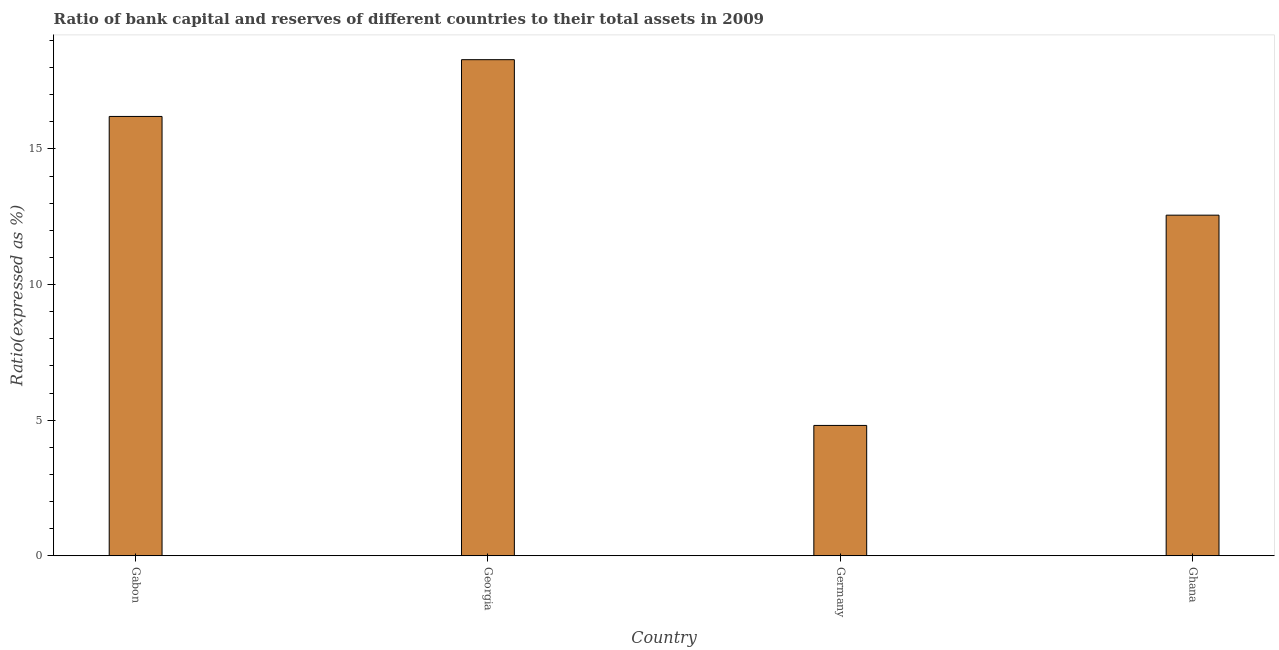What is the title of the graph?
Keep it short and to the point. Ratio of bank capital and reserves of different countries to their total assets in 2009. What is the label or title of the Y-axis?
Offer a very short reply. Ratio(expressed as %). What is the bank capital to assets ratio in Ghana?
Your answer should be compact. 12.56. Across all countries, what is the maximum bank capital to assets ratio?
Make the answer very short. 18.29. Across all countries, what is the minimum bank capital to assets ratio?
Offer a very short reply. 4.81. In which country was the bank capital to assets ratio maximum?
Your answer should be compact. Georgia. What is the sum of the bank capital to assets ratio?
Give a very brief answer. 51.86. What is the difference between the bank capital to assets ratio in Georgia and Ghana?
Ensure brevity in your answer.  5.73. What is the average bank capital to assets ratio per country?
Keep it short and to the point. 12.96. What is the median bank capital to assets ratio?
Your answer should be very brief. 14.38. In how many countries, is the bank capital to assets ratio greater than 13 %?
Ensure brevity in your answer.  2. What is the ratio of the bank capital to assets ratio in Gabon to that in Ghana?
Your response must be concise. 1.29. Is the bank capital to assets ratio in Georgia less than that in Ghana?
Your answer should be very brief. No. What is the difference between the highest and the second highest bank capital to assets ratio?
Make the answer very short. 2.09. What is the difference between the highest and the lowest bank capital to assets ratio?
Your response must be concise. 13.49. How many bars are there?
Offer a terse response. 4. What is the difference between two consecutive major ticks on the Y-axis?
Your answer should be compact. 5. Are the values on the major ticks of Y-axis written in scientific E-notation?
Your response must be concise. No. What is the Ratio(expressed as %) in Gabon?
Ensure brevity in your answer.  16.2. What is the Ratio(expressed as %) in Georgia?
Your answer should be very brief. 18.29. What is the Ratio(expressed as %) in Germany?
Offer a very short reply. 4.81. What is the Ratio(expressed as %) of Ghana?
Keep it short and to the point. 12.56. What is the difference between the Ratio(expressed as %) in Gabon and Georgia?
Provide a short and direct response. -2.09. What is the difference between the Ratio(expressed as %) in Gabon and Germany?
Ensure brevity in your answer.  11.39. What is the difference between the Ratio(expressed as %) in Gabon and Ghana?
Provide a short and direct response. 3.64. What is the difference between the Ratio(expressed as %) in Georgia and Germany?
Give a very brief answer. 13.49. What is the difference between the Ratio(expressed as %) in Georgia and Ghana?
Offer a terse response. 5.73. What is the difference between the Ratio(expressed as %) in Germany and Ghana?
Give a very brief answer. -7.75. What is the ratio of the Ratio(expressed as %) in Gabon to that in Georgia?
Give a very brief answer. 0.89. What is the ratio of the Ratio(expressed as %) in Gabon to that in Germany?
Offer a terse response. 3.37. What is the ratio of the Ratio(expressed as %) in Gabon to that in Ghana?
Provide a succinct answer. 1.29. What is the ratio of the Ratio(expressed as %) in Georgia to that in Germany?
Offer a very short reply. 3.81. What is the ratio of the Ratio(expressed as %) in Georgia to that in Ghana?
Your response must be concise. 1.46. What is the ratio of the Ratio(expressed as %) in Germany to that in Ghana?
Provide a short and direct response. 0.38. 